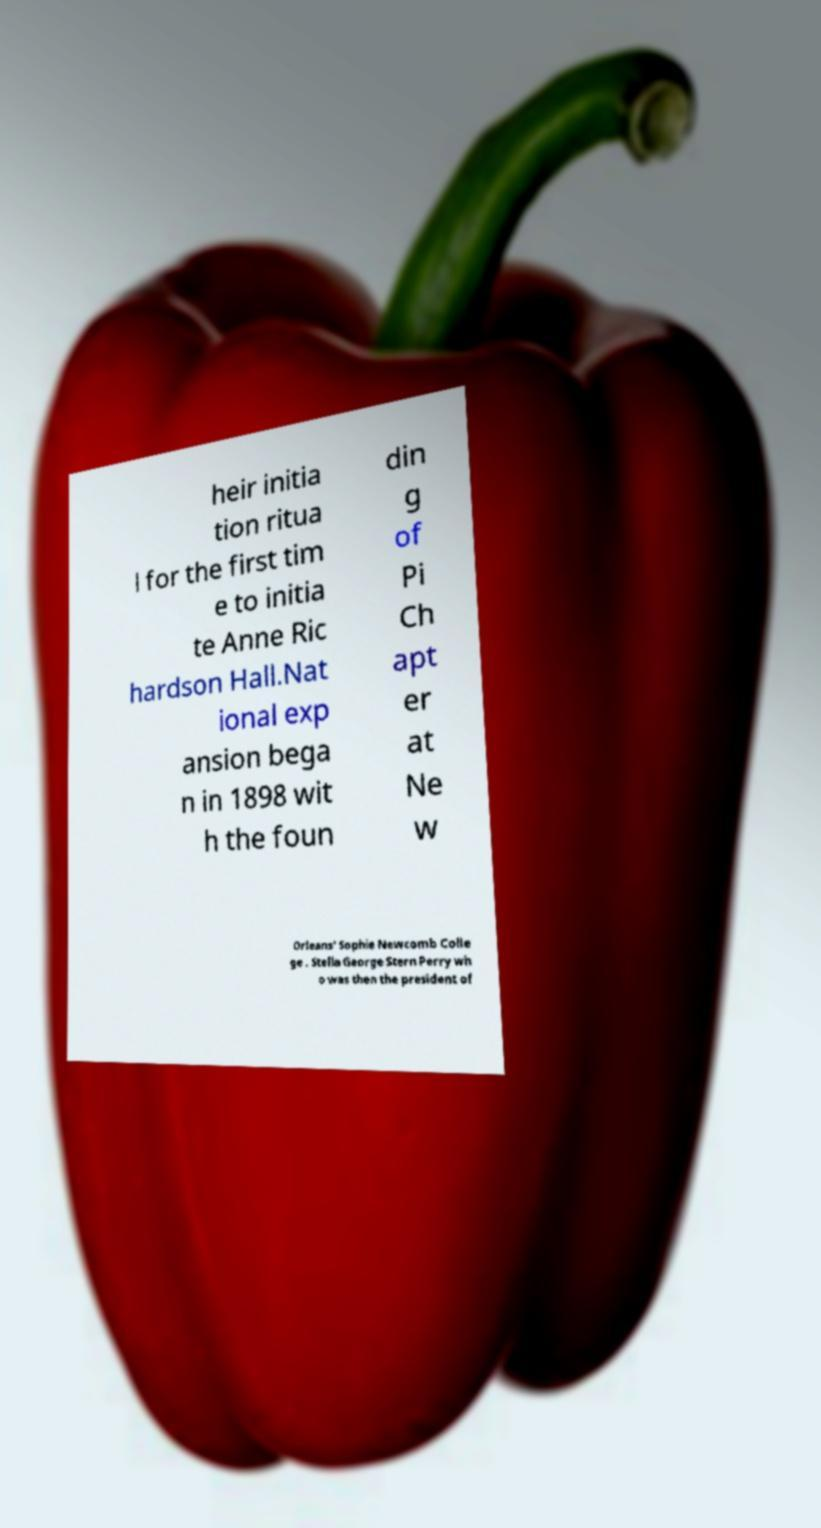Please read and relay the text visible in this image. What does it say? heir initia tion ritua l for the first tim e to initia te Anne Ric hardson Hall.Nat ional exp ansion bega n in 1898 wit h the foun din g of Pi Ch apt er at Ne w Orleans' Sophie Newcomb Colle ge . Stella George Stern Perry wh o was then the president of 